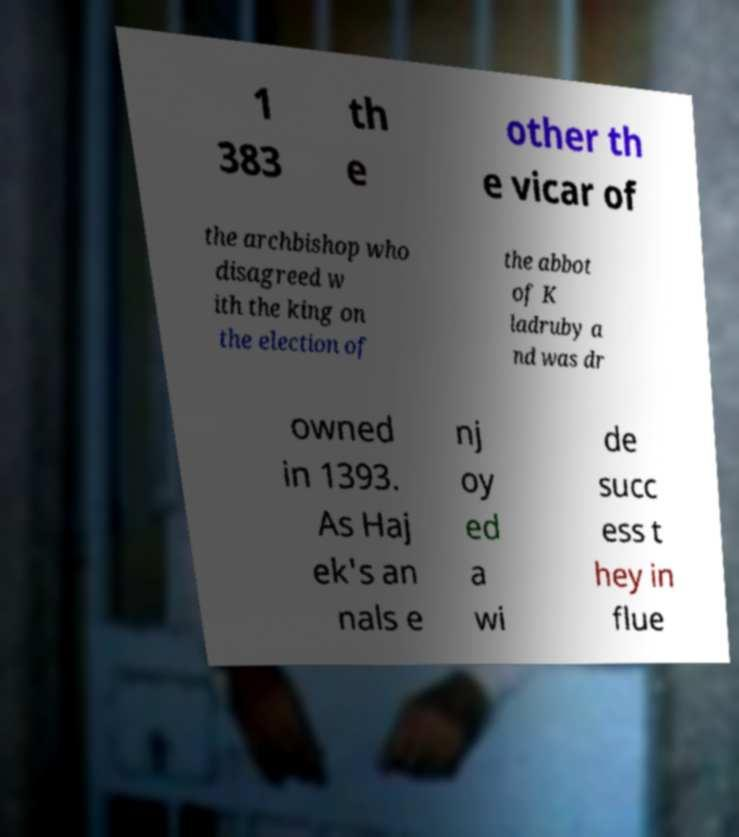Please read and relay the text visible in this image. What does it say? 1 383 th e other th e vicar of the archbishop who disagreed w ith the king on the election of the abbot of K ladruby a nd was dr owned in 1393. As Haj ek's an nals e nj oy ed a wi de succ ess t hey in flue 